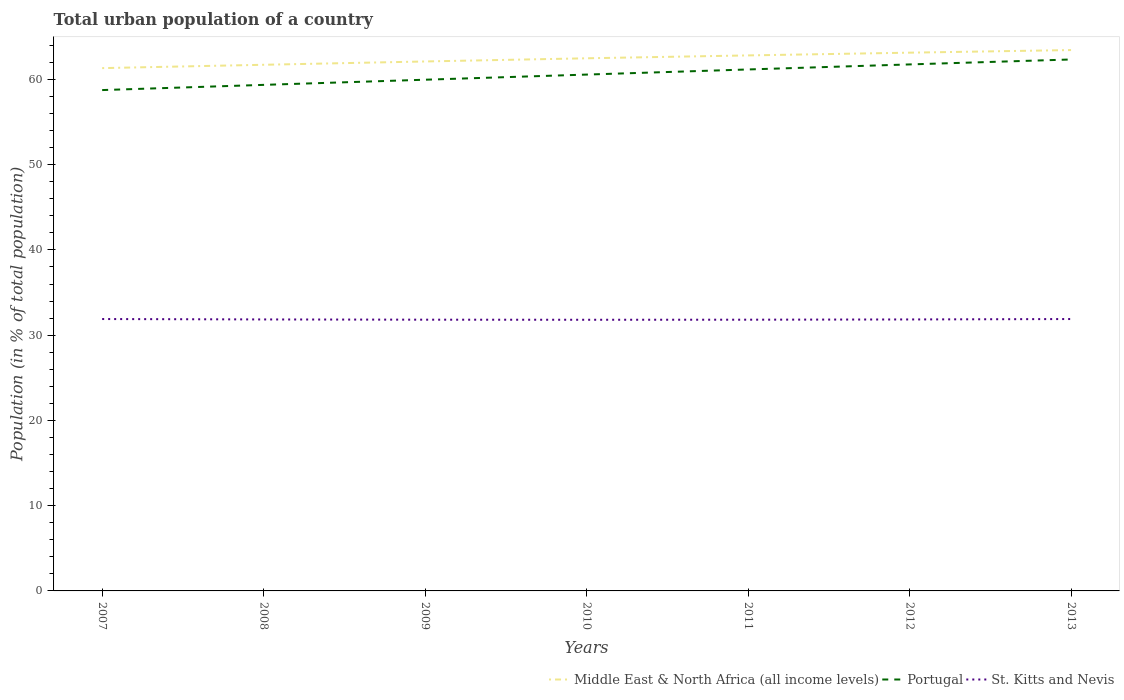How many different coloured lines are there?
Provide a succinct answer. 3. Does the line corresponding to Portugal intersect with the line corresponding to St. Kitts and Nevis?
Make the answer very short. No. Across all years, what is the maximum urban population in St. Kitts and Nevis?
Provide a succinct answer. 31.81. In which year was the urban population in St. Kitts and Nevis maximum?
Your answer should be compact. 2010. What is the total urban population in St. Kitts and Nevis in the graph?
Provide a succinct answer. 0.05. What is the difference between the highest and the second highest urban population in Middle East & North Africa (all income levels)?
Keep it short and to the point. 2.12. How many years are there in the graph?
Ensure brevity in your answer.  7. What is the difference between two consecutive major ticks on the Y-axis?
Provide a succinct answer. 10. Are the values on the major ticks of Y-axis written in scientific E-notation?
Offer a very short reply. No. Does the graph contain any zero values?
Keep it short and to the point. No. Does the graph contain grids?
Offer a terse response. No. What is the title of the graph?
Ensure brevity in your answer.  Total urban population of a country. Does "Lithuania" appear as one of the legend labels in the graph?
Ensure brevity in your answer.  No. What is the label or title of the X-axis?
Offer a terse response. Years. What is the label or title of the Y-axis?
Give a very brief answer. Population (in % of total population). What is the Population (in % of total population) in Middle East & North Africa (all income levels) in 2007?
Your answer should be compact. 61.32. What is the Population (in % of total population) of Portugal in 2007?
Offer a terse response. 58.75. What is the Population (in % of total population) in St. Kitts and Nevis in 2007?
Give a very brief answer. 31.89. What is the Population (in % of total population) in Middle East & North Africa (all income levels) in 2008?
Your answer should be very brief. 61.72. What is the Population (in % of total population) of Portugal in 2008?
Offer a terse response. 59.36. What is the Population (in % of total population) of St. Kitts and Nevis in 2008?
Provide a succinct answer. 31.84. What is the Population (in % of total population) in Middle East & North Africa (all income levels) in 2009?
Provide a short and direct response. 62.1. What is the Population (in % of total population) in Portugal in 2009?
Your answer should be very brief. 59.96. What is the Population (in % of total population) of St. Kitts and Nevis in 2009?
Ensure brevity in your answer.  31.82. What is the Population (in % of total population) of Middle East & North Africa (all income levels) in 2010?
Make the answer very short. 62.48. What is the Population (in % of total population) of Portugal in 2010?
Your answer should be very brief. 60.57. What is the Population (in % of total population) of St. Kitts and Nevis in 2010?
Provide a succinct answer. 31.81. What is the Population (in % of total population) in Middle East & North Africa (all income levels) in 2011?
Give a very brief answer. 62.81. What is the Population (in % of total population) in Portugal in 2011?
Provide a succinct answer. 61.17. What is the Population (in % of total population) of St. Kitts and Nevis in 2011?
Provide a short and direct response. 31.82. What is the Population (in % of total population) of Middle East & North Africa (all income levels) in 2012?
Keep it short and to the point. 63.14. What is the Population (in % of total population) in Portugal in 2012?
Make the answer very short. 61.76. What is the Population (in % of total population) in St. Kitts and Nevis in 2012?
Provide a succinct answer. 31.84. What is the Population (in % of total population) of Middle East & North Africa (all income levels) in 2013?
Provide a succinct answer. 63.44. What is the Population (in % of total population) of Portugal in 2013?
Give a very brief answer. 62.34. What is the Population (in % of total population) of St. Kitts and Nevis in 2013?
Your response must be concise. 31.89. Across all years, what is the maximum Population (in % of total population) of Middle East & North Africa (all income levels)?
Your response must be concise. 63.44. Across all years, what is the maximum Population (in % of total population) of Portugal?
Your response must be concise. 62.34. Across all years, what is the maximum Population (in % of total population) of St. Kitts and Nevis?
Ensure brevity in your answer.  31.89. Across all years, what is the minimum Population (in % of total population) in Middle East & North Africa (all income levels)?
Ensure brevity in your answer.  61.32. Across all years, what is the minimum Population (in % of total population) of Portugal?
Provide a short and direct response. 58.75. Across all years, what is the minimum Population (in % of total population) in St. Kitts and Nevis?
Keep it short and to the point. 31.81. What is the total Population (in % of total population) in Middle East & North Africa (all income levels) in the graph?
Your response must be concise. 437.02. What is the total Population (in % of total population) in Portugal in the graph?
Your answer should be compact. 423.9. What is the total Population (in % of total population) of St. Kitts and Nevis in the graph?
Offer a very short reply. 222.91. What is the difference between the Population (in % of total population) of Middle East & North Africa (all income levels) in 2007 and that in 2008?
Give a very brief answer. -0.39. What is the difference between the Population (in % of total population) of Portugal in 2007 and that in 2008?
Offer a terse response. -0.61. What is the difference between the Population (in % of total population) of St. Kitts and Nevis in 2007 and that in 2008?
Ensure brevity in your answer.  0.05. What is the difference between the Population (in % of total population) in Middle East & North Africa (all income levels) in 2007 and that in 2009?
Offer a terse response. -0.78. What is the difference between the Population (in % of total population) of Portugal in 2007 and that in 2009?
Provide a short and direct response. -1.22. What is the difference between the Population (in % of total population) in St. Kitts and Nevis in 2007 and that in 2009?
Offer a terse response. 0.08. What is the difference between the Population (in % of total population) of Middle East & North Africa (all income levels) in 2007 and that in 2010?
Your answer should be very brief. -1.15. What is the difference between the Population (in % of total population) in Portugal in 2007 and that in 2010?
Give a very brief answer. -1.82. What is the difference between the Population (in % of total population) of St. Kitts and Nevis in 2007 and that in 2010?
Your answer should be compact. 0.09. What is the difference between the Population (in % of total population) of Middle East & North Africa (all income levels) in 2007 and that in 2011?
Make the answer very short. -1.49. What is the difference between the Population (in % of total population) in Portugal in 2007 and that in 2011?
Your answer should be very brief. -2.42. What is the difference between the Population (in % of total population) in St. Kitts and Nevis in 2007 and that in 2011?
Provide a succinct answer. 0.08. What is the difference between the Population (in % of total population) of Middle East & North Africa (all income levels) in 2007 and that in 2012?
Your answer should be very brief. -1.81. What is the difference between the Population (in % of total population) of Portugal in 2007 and that in 2012?
Offer a very short reply. -3.01. What is the difference between the Population (in % of total population) of St. Kitts and Nevis in 2007 and that in 2012?
Make the answer very short. 0.05. What is the difference between the Population (in % of total population) in Middle East & North Africa (all income levels) in 2007 and that in 2013?
Your response must be concise. -2.12. What is the difference between the Population (in % of total population) in Portugal in 2007 and that in 2013?
Ensure brevity in your answer.  -3.59. What is the difference between the Population (in % of total population) in Middle East & North Africa (all income levels) in 2008 and that in 2009?
Your answer should be compact. -0.39. What is the difference between the Population (in % of total population) of Portugal in 2008 and that in 2009?
Your response must be concise. -0.6. What is the difference between the Population (in % of total population) in St. Kitts and Nevis in 2008 and that in 2009?
Provide a succinct answer. 0.03. What is the difference between the Population (in % of total population) in Middle East & North Africa (all income levels) in 2008 and that in 2010?
Ensure brevity in your answer.  -0.76. What is the difference between the Population (in % of total population) of Portugal in 2008 and that in 2010?
Offer a very short reply. -1.21. What is the difference between the Population (in % of total population) in St. Kitts and Nevis in 2008 and that in 2010?
Your answer should be compact. 0.04. What is the difference between the Population (in % of total population) of Middle East & North Africa (all income levels) in 2008 and that in 2011?
Your answer should be compact. -1.1. What is the difference between the Population (in % of total population) of Portugal in 2008 and that in 2011?
Provide a succinct answer. -1.81. What is the difference between the Population (in % of total population) in St. Kitts and Nevis in 2008 and that in 2011?
Your response must be concise. 0.03. What is the difference between the Population (in % of total population) of Middle East & North Africa (all income levels) in 2008 and that in 2012?
Make the answer very short. -1.42. What is the difference between the Population (in % of total population) of Portugal in 2008 and that in 2012?
Offer a very short reply. -2.4. What is the difference between the Population (in % of total population) of Middle East & North Africa (all income levels) in 2008 and that in 2013?
Offer a very short reply. -1.73. What is the difference between the Population (in % of total population) in Portugal in 2008 and that in 2013?
Make the answer very short. -2.98. What is the difference between the Population (in % of total population) in St. Kitts and Nevis in 2008 and that in 2013?
Make the answer very short. -0.05. What is the difference between the Population (in % of total population) of Middle East & North Africa (all income levels) in 2009 and that in 2010?
Your answer should be very brief. -0.37. What is the difference between the Population (in % of total population) of Portugal in 2009 and that in 2010?
Ensure brevity in your answer.  -0.6. What is the difference between the Population (in % of total population) in St. Kitts and Nevis in 2009 and that in 2010?
Offer a terse response. 0.01. What is the difference between the Population (in % of total population) in Middle East & North Africa (all income levels) in 2009 and that in 2011?
Offer a very short reply. -0.71. What is the difference between the Population (in % of total population) of Portugal in 2009 and that in 2011?
Your response must be concise. -1.2. What is the difference between the Population (in % of total population) of St. Kitts and Nevis in 2009 and that in 2011?
Offer a very short reply. 0. What is the difference between the Population (in % of total population) in Middle East & North Africa (all income levels) in 2009 and that in 2012?
Offer a very short reply. -1.03. What is the difference between the Population (in % of total population) in Portugal in 2009 and that in 2012?
Give a very brief answer. -1.79. What is the difference between the Population (in % of total population) of St. Kitts and Nevis in 2009 and that in 2012?
Offer a terse response. -0.03. What is the difference between the Population (in % of total population) in Middle East & North Africa (all income levels) in 2009 and that in 2013?
Provide a succinct answer. -1.34. What is the difference between the Population (in % of total population) of Portugal in 2009 and that in 2013?
Offer a very short reply. -2.37. What is the difference between the Population (in % of total population) in St. Kitts and Nevis in 2009 and that in 2013?
Give a very brief answer. -0.08. What is the difference between the Population (in % of total population) of Middle East & North Africa (all income levels) in 2010 and that in 2011?
Provide a short and direct response. -0.34. What is the difference between the Population (in % of total population) of Portugal in 2010 and that in 2011?
Your answer should be very brief. -0.6. What is the difference between the Population (in % of total population) in St. Kitts and Nevis in 2010 and that in 2011?
Offer a very short reply. -0.01. What is the difference between the Population (in % of total population) of Middle East & North Africa (all income levels) in 2010 and that in 2012?
Provide a short and direct response. -0.66. What is the difference between the Population (in % of total population) in Portugal in 2010 and that in 2012?
Your answer should be very brief. -1.19. What is the difference between the Population (in % of total population) in St. Kitts and Nevis in 2010 and that in 2012?
Your answer should be compact. -0.04. What is the difference between the Population (in % of total population) in Middle East & North Africa (all income levels) in 2010 and that in 2013?
Your answer should be compact. -0.97. What is the difference between the Population (in % of total population) in Portugal in 2010 and that in 2013?
Make the answer very short. -1.77. What is the difference between the Population (in % of total population) of St. Kitts and Nevis in 2010 and that in 2013?
Your response must be concise. -0.09. What is the difference between the Population (in % of total population) of Middle East & North Africa (all income levels) in 2011 and that in 2012?
Keep it short and to the point. -0.32. What is the difference between the Population (in % of total population) of Portugal in 2011 and that in 2012?
Your response must be concise. -0.59. What is the difference between the Population (in % of total population) of St. Kitts and Nevis in 2011 and that in 2012?
Provide a short and direct response. -0.03. What is the difference between the Population (in % of total population) in Middle East & North Africa (all income levels) in 2011 and that in 2013?
Make the answer very short. -0.63. What is the difference between the Population (in % of total population) of Portugal in 2011 and that in 2013?
Ensure brevity in your answer.  -1.17. What is the difference between the Population (in % of total population) of St. Kitts and Nevis in 2011 and that in 2013?
Your response must be concise. -0.08. What is the difference between the Population (in % of total population) in Middle East & North Africa (all income levels) in 2012 and that in 2013?
Make the answer very short. -0.31. What is the difference between the Population (in % of total population) of Portugal in 2012 and that in 2013?
Your answer should be very brief. -0.58. What is the difference between the Population (in % of total population) of St. Kitts and Nevis in 2012 and that in 2013?
Your answer should be very brief. -0.05. What is the difference between the Population (in % of total population) of Middle East & North Africa (all income levels) in 2007 and the Population (in % of total population) of Portugal in 2008?
Ensure brevity in your answer.  1.97. What is the difference between the Population (in % of total population) of Middle East & North Africa (all income levels) in 2007 and the Population (in % of total population) of St. Kitts and Nevis in 2008?
Provide a succinct answer. 29.48. What is the difference between the Population (in % of total population) of Portugal in 2007 and the Population (in % of total population) of St. Kitts and Nevis in 2008?
Your response must be concise. 26.9. What is the difference between the Population (in % of total population) in Middle East & North Africa (all income levels) in 2007 and the Population (in % of total population) in Portugal in 2009?
Provide a short and direct response. 1.36. What is the difference between the Population (in % of total population) in Middle East & North Africa (all income levels) in 2007 and the Population (in % of total population) in St. Kitts and Nevis in 2009?
Give a very brief answer. 29.51. What is the difference between the Population (in % of total population) of Portugal in 2007 and the Population (in % of total population) of St. Kitts and Nevis in 2009?
Provide a succinct answer. 26.93. What is the difference between the Population (in % of total population) in Middle East & North Africa (all income levels) in 2007 and the Population (in % of total population) in Portugal in 2010?
Your answer should be very brief. 0.76. What is the difference between the Population (in % of total population) in Middle East & North Africa (all income levels) in 2007 and the Population (in % of total population) in St. Kitts and Nevis in 2010?
Your response must be concise. 29.52. What is the difference between the Population (in % of total population) of Portugal in 2007 and the Population (in % of total population) of St. Kitts and Nevis in 2010?
Your answer should be very brief. 26.94. What is the difference between the Population (in % of total population) in Middle East & North Africa (all income levels) in 2007 and the Population (in % of total population) in Portugal in 2011?
Give a very brief answer. 0.16. What is the difference between the Population (in % of total population) of Middle East & North Africa (all income levels) in 2007 and the Population (in % of total population) of St. Kitts and Nevis in 2011?
Provide a succinct answer. 29.51. What is the difference between the Population (in % of total population) in Portugal in 2007 and the Population (in % of total population) in St. Kitts and Nevis in 2011?
Offer a very short reply. 26.93. What is the difference between the Population (in % of total population) in Middle East & North Africa (all income levels) in 2007 and the Population (in % of total population) in Portugal in 2012?
Provide a short and direct response. -0.43. What is the difference between the Population (in % of total population) in Middle East & North Africa (all income levels) in 2007 and the Population (in % of total population) in St. Kitts and Nevis in 2012?
Ensure brevity in your answer.  29.48. What is the difference between the Population (in % of total population) of Portugal in 2007 and the Population (in % of total population) of St. Kitts and Nevis in 2012?
Give a very brief answer. 26.91. What is the difference between the Population (in % of total population) in Middle East & North Africa (all income levels) in 2007 and the Population (in % of total population) in Portugal in 2013?
Provide a succinct answer. -1.01. What is the difference between the Population (in % of total population) in Middle East & North Africa (all income levels) in 2007 and the Population (in % of total population) in St. Kitts and Nevis in 2013?
Provide a succinct answer. 29.43. What is the difference between the Population (in % of total population) of Portugal in 2007 and the Population (in % of total population) of St. Kitts and Nevis in 2013?
Provide a short and direct response. 26.86. What is the difference between the Population (in % of total population) of Middle East & North Africa (all income levels) in 2008 and the Population (in % of total population) of Portugal in 2009?
Give a very brief answer. 1.75. What is the difference between the Population (in % of total population) of Middle East & North Africa (all income levels) in 2008 and the Population (in % of total population) of St. Kitts and Nevis in 2009?
Your answer should be very brief. 29.9. What is the difference between the Population (in % of total population) in Portugal in 2008 and the Population (in % of total population) in St. Kitts and Nevis in 2009?
Your answer should be compact. 27.54. What is the difference between the Population (in % of total population) of Middle East & North Africa (all income levels) in 2008 and the Population (in % of total population) of Portugal in 2010?
Give a very brief answer. 1.15. What is the difference between the Population (in % of total population) in Middle East & North Africa (all income levels) in 2008 and the Population (in % of total population) in St. Kitts and Nevis in 2010?
Offer a terse response. 29.91. What is the difference between the Population (in % of total population) of Portugal in 2008 and the Population (in % of total population) of St. Kitts and Nevis in 2010?
Keep it short and to the point. 27.55. What is the difference between the Population (in % of total population) in Middle East & North Africa (all income levels) in 2008 and the Population (in % of total population) in Portugal in 2011?
Offer a very short reply. 0.55. What is the difference between the Population (in % of total population) of Middle East & North Africa (all income levels) in 2008 and the Population (in % of total population) of St. Kitts and Nevis in 2011?
Provide a succinct answer. 29.9. What is the difference between the Population (in % of total population) of Portugal in 2008 and the Population (in % of total population) of St. Kitts and Nevis in 2011?
Provide a succinct answer. 27.54. What is the difference between the Population (in % of total population) of Middle East & North Africa (all income levels) in 2008 and the Population (in % of total population) of Portugal in 2012?
Provide a succinct answer. -0.04. What is the difference between the Population (in % of total population) in Middle East & North Africa (all income levels) in 2008 and the Population (in % of total population) in St. Kitts and Nevis in 2012?
Your answer should be compact. 29.87. What is the difference between the Population (in % of total population) of Portugal in 2008 and the Population (in % of total population) of St. Kitts and Nevis in 2012?
Your response must be concise. 27.52. What is the difference between the Population (in % of total population) of Middle East & North Africa (all income levels) in 2008 and the Population (in % of total population) of Portugal in 2013?
Make the answer very short. -0.62. What is the difference between the Population (in % of total population) of Middle East & North Africa (all income levels) in 2008 and the Population (in % of total population) of St. Kitts and Nevis in 2013?
Provide a short and direct response. 29.82. What is the difference between the Population (in % of total population) of Portugal in 2008 and the Population (in % of total population) of St. Kitts and Nevis in 2013?
Keep it short and to the point. 27.47. What is the difference between the Population (in % of total population) in Middle East & North Africa (all income levels) in 2009 and the Population (in % of total population) in Portugal in 2010?
Ensure brevity in your answer.  1.54. What is the difference between the Population (in % of total population) of Middle East & North Africa (all income levels) in 2009 and the Population (in % of total population) of St. Kitts and Nevis in 2010?
Your response must be concise. 30.3. What is the difference between the Population (in % of total population) in Portugal in 2009 and the Population (in % of total population) in St. Kitts and Nevis in 2010?
Your answer should be compact. 28.16. What is the difference between the Population (in % of total population) in Middle East & North Africa (all income levels) in 2009 and the Population (in % of total population) in Portugal in 2011?
Give a very brief answer. 0.94. What is the difference between the Population (in % of total population) of Middle East & North Africa (all income levels) in 2009 and the Population (in % of total population) of St. Kitts and Nevis in 2011?
Your answer should be compact. 30.29. What is the difference between the Population (in % of total population) of Portugal in 2009 and the Population (in % of total population) of St. Kitts and Nevis in 2011?
Ensure brevity in your answer.  28.15. What is the difference between the Population (in % of total population) of Middle East & North Africa (all income levels) in 2009 and the Population (in % of total population) of Portugal in 2012?
Ensure brevity in your answer.  0.35. What is the difference between the Population (in % of total population) in Middle East & North Africa (all income levels) in 2009 and the Population (in % of total population) in St. Kitts and Nevis in 2012?
Offer a terse response. 30.26. What is the difference between the Population (in % of total population) of Portugal in 2009 and the Population (in % of total population) of St. Kitts and Nevis in 2012?
Your response must be concise. 28.12. What is the difference between the Population (in % of total population) in Middle East & North Africa (all income levels) in 2009 and the Population (in % of total population) in Portugal in 2013?
Give a very brief answer. -0.23. What is the difference between the Population (in % of total population) in Middle East & North Africa (all income levels) in 2009 and the Population (in % of total population) in St. Kitts and Nevis in 2013?
Your response must be concise. 30.21. What is the difference between the Population (in % of total population) of Portugal in 2009 and the Population (in % of total population) of St. Kitts and Nevis in 2013?
Your response must be concise. 28.07. What is the difference between the Population (in % of total population) of Middle East & North Africa (all income levels) in 2010 and the Population (in % of total population) of Portugal in 2011?
Make the answer very short. 1.31. What is the difference between the Population (in % of total population) in Middle East & North Africa (all income levels) in 2010 and the Population (in % of total population) in St. Kitts and Nevis in 2011?
Give a very brief answer. 30.66. What is the difference between the Population (in % of total population) of Portugal in 2010 and the Population (in % of total population) of St. Kitts and Nevis in 2011?
Make the answer very short. 28.75. What is the difference between the Population (in % of total population) in Middle East & North Africa (all income levels) in 2010 and the Population (in % of total population) in Portugal in 2012?
Offer a very short reply. 0.72. What is the difference between the Population (in % of total population) in Middle East & North Africa (all income levels) in 2010 and the Population (in % of total population) in St. Kitts and Nevis in 2012?
Provide a short and direct response. 30.63. What is the difference between the Population (in % of total population) of Portugal in 2010 and the Population (in % of total population) of St. Kitts and Nevis in 2012?
Offer a very short reply. 28.72. What is the difference between the Population (in % of total population) of Middle East & North Africa (all income levels) in 2010 and the Population (in % of total population) of Portugal in 2013?
Provide a short and direct response. 0.14. What is the difference between the Population (in % of total population) of Middle East & North Africa (all income levels) in 2010 and the Population (in % of total population) of St. Kitts and Nevis in 2013?
Ensure brevity in your answer.  30.59. What is the difference between the Population (in % of total population) of Portugal in 2010 and the Population (in % of total population) of St. Kitts and Nevis in 2013?
Give a very brief answer. 28.68. What is the difference between the Population (in % of total population) of Middle East & North Africa (all income levels) in 2011 and the Population (in % of total population) of Portugal in 2012?
Provide a succinct answer. 1.06. What is the difference between the Population (in % of total population) of Middle East & North Africa (all income levels) in 2011 and the Population (in % of total population) of St. Kitts and Nevis in 2012?
Provide a short and direct response. 30.97. What is the difference between the Population (in % of total population) of Portugal in 2011 and the Population (in % of total population) of St. Kitts and Nevis in 2012?
Make the answer very short. 29.32. What is the difference between the Population (in % of total population) of Middle East & North Africa (all income levels) in 2011 and the Population (in % of total population) of Portugal in 2013?
Your response must be concise. 0.48. What is the difference between the Population (in % of total population) in Middle East & North Africa (all income levels) in 2011 and the Population (in % of total population) in St. Kitts and Nevis in 2013?
Offer a very short reply. 30.92. What is the difference between the Population (in % of total population) in Portugal in 2011 and the Population (in % of total population) in St. Kitts and Nevis in 2013?
Your answer should be very brief. 29.27. What is the difference between the Population (in % of total population) in Middle East & North Africa (all income levels) in 2012 and the Population (in % of total population) in Portugal in 2013?
Give a very brief answer. 0.8. What is the difference between the Population (in % of total population) in Middle East & North Africa (all income levels) in 2012 and the Population (in % of total population) in St. Kitts and Nevis in 2013?
Provide a succinct answer. 31.24. What is the difference between the Population (in % of total population) in Portugal in 2012 and the Population (in % of total population) in St. Kitts and Nevis in 2013?
Give a very brief answer. 29.87. What is the average Population (in % of total population) of Middle East & North Africa (all income levels) per year?
Give a very brief answer. 62.43. What is the average Population (in % of total population) in Portugal per year?
Make the answer very short. 60.56. What is the average Population (in % of total population) of St. Kitts and Nevis per year?
Your answer should be compact. 31.84. In the year 2007, what is the difference between the Population (in % of total population) of Middle East & North Africa (all income levels) and Population (in % of total population) of Portugal?
Provide a short and direct response. 2.58. In the year 2007, what is the difference between the Population (in % of total population) in Middle East & North Africa (all income levels) and Population (in % of total population) in St. Kitts and Nevis?
Your answer should be compact. 29.43. In the year 2007, what is the difference between the Population (in % of total population) of Portugal and Population (in % of total population) of St. Kitts and Nevis?
Your answer should be very brief. 26.86. In the year 2008, what is the difference between the Population (in % of total population) of Middle East & North Africa (all income levels) and Population (in % of total population) of Portugal?
Your response must be concise. 2.36. In the year 2008, what is the difference between the Population (in % of total population) in Middle East & North Africa (all income levels) and Population (in % of total population) in St. Kitts and Nevis?
Make the answer very short. 29.87. In the year 2008, what is the difference between the Population (in % of total population) in Portugal and Population (in % of total population) in St. Kitts and Nevis?
Your response must be concise. 27.51. In the year 2009, what is the difference between the Population (in % of total population) in Middle East & North Africa (all income levels) and Population (in % of total population) in Portugal?
Make the answer very short. 2.14. In the year 2009, what is the difference between the Population (in % of total population) of Middle East & North Africa (all income levels) and Population (in % of total population) of St. Kitts and Nevis?
Offer a terse response. 30.29. In the year 2009, what is the difference between the Population (in % of total population) in Portugal and Population (in % of total population) in St. Kitts and Nevis?
Your answer should be very brief. 28.15. In the year 2010, what is the difference between the Population (in % of total population) in Middle East & North Africa (all income levels) and Population (in % of total population) in Portugal?
Your response must be concise. 1.91. In the year 2010, what is the difference between the Population (in % of total population) of Middle East & North Africa (all income levels) and Population (in % of total population) of St. Kitts and Nevis?
Your answer should be very brief. 30.67. In the year 2010, what is the difference between the Population (in % of total population) in Portugal and Population (in % of total population) in St. Kitts and Nevis?
Keep it short and to the point. 28.76. In the year 2011, what is the difference between the Population (in % of total population) of Middle East & North Africa (all income levels) and Population (in % of total population) of Portugal?
Offer a terse response. 1.65. In the year 2011, what is the difference between the Population (in % of total population) in Middle East & North Africa (all income levels) and Population (in % of total population) in St. Kitts and Nevis?
Your response must be concise. 31. In the year 2011, what is the difference between the Population (in % of total population) of Portugal and Population (in % of total population) of St. Kitts and Nevis?
Your answer should be very brief. 29.35. In the year 2012, what is the difference between the Population (in % of total population) of Middle East & North Africa (all income levels) and Population (in % of total population) of Portugal?
Ensure brevity in your answer.  1.38. In the year 2012, what is the difference between the Population (in % of total population) in Middle East & North Africa (all income levels) and Population (in % of total population) in St. Kitts and Nevis?
Provide a succinct answer. 31.29. In the year 2012, what is the difference between the Population (in % of total population) of Portugal and Population (in % of total population) of St. Kitts and Nevis?
Make the answer very short. 29.91. In the year 2013, what is the difference between the Population (in % of total population) of Middle East & North Africa (all income levels) and Population (in % of total population) of Portugal?
Offer a terse response. 1.1. In the year 2013, what is the difference between the Population (in % of total population) in Middle East & North Africa (all income levels) and Population (in % of total population) in St. Kitts and Nevis?
Your response must be concise. 31.55. In the year 2013, what is the difference between the Population (in % of total population) of Portugal and Population (in % of total population) of St. Kitts and Nevis?
Give a very brief answer. 30.45. What is the ratio of the Population (in % of total population) in Middle East & North Africa (all income levels) in 2007 to that in 2008?
Give a very brief answer. 0.99. What is the ratio of the Population (in % of total population) of Portugal in 2007 to that in 2008?
Offer a very short reply. 0.99. What is the ratio of the Population (in % of total population) in Middle East & North Africa (all income levels) in 2007 to that in 2009?
Provide a short and direct response. 0.99. What is the ratio of the Population (in % of total population) in Portugal in 2007 to that in 2009?
Offer a very short reply. 0.98. What is the ratio of the Population (in % of total population) in St. Kitts and Nevis in 2007 to that in 2009?
Provide a succinct answer. 1. What is the ratio of the Population (in % of total population) in Middle East & North Africa (all income levels) in 2007 to that in 2010?
Your response must be concise. 0.98. What is the ratio of the Population (in % of total population) of Portugal in 2007 to that in 2010?
Your answer should be very brief. 0.97. What is the ratio of the Population (in % of total population) in Middle East & North Africa (all income levels) in 2007 to that in 2011?
Make the answer very short. 0.98. What is the ratio of the Population (in % of total population) in Portugal in 2007 to that in 2011?
Your response must be concise. 0.96. What is the ratio of the Population (in % of total population) of St. Kitts and Nevis in 2007 to that in 2011?
Offer a terse response. 1. What is the ratio of the Population (in % of total population) of Middle East & North Africa (all income levels) in 2007 to that in 2012?
Offer a terse response. 0.97. What is the ratio of the Population (in % of total population) in Portugal in 2007 to that in 2012?
Provide a short and direct response. 0.95. What is the ratio of the Population (in % of total population) of St. Kitts and Nevis in 2007 to that in 2012?
Ensure brevity in your answer.  1. What is the ratio of the Population (in % of total population) of Middle East & North Africa (all income levels) in 2007 to that in 2013?
Ensure brevity in your answer.  0.97. What is the ratio of the Population (in % of total population) in Portugal in 2007 to that in 2013?
Provide a succinct answer. 0.94. What is the ratio of the Population (in % of total population) in Portugal in 2008 to that in 2010?
Offer a terse response. 0.98. What is the ratio of the Population (in % of total population) in St. Kitts and Nevis in 2008 to that in 2010?
Provide a short and direct response. 1. What is the ratio of the Population (in % of total population) of Middle East & North Africa (all income levels) in 2008 to that in 2011?
Make the answer very short. 0.98. What is the ratio of the Population (in % of total population) of Portugal in 2008 to that in 2011?
Give a very brief answer. 0.97. What is the ratio of the Population (in % of total population) of Middle East & North Africa (all income levels) in 2008 to that in 2012?
Your answer should be compact. 0.98. What is the ratio of the Population (in % of total population) in Portugal in 2008 to that in 2012?
Your answer should be compact. 0.96. What is the ratio of the Population (in % of total population) in St. Kitts and Nevis in 2008 to that in 2012?
Provide a succinct answer. 1. What is the ratio of the Population (in % of total population) of Middle East & North Africa (all income levels) in 2008 to that in 2013?
Offer a very short reply. 0.97. What is the ratio of the Population (in % of total population) of Portugal in 2008 to that in 2013?
Provide a short and direct response. 0.95. What is the ratio of the Population (in % of total population) of St. Kitts and Nevis in 2008 to that in 2013?
Provide a succinct answer. 1. What is the ratio of the Population (in % of total population) of Portugal in 2009 to that in 2010?
Offer a very short reply. 0.99. What is the ratio of the Population (in % of total population) in Middle East & North Africa (all income levels) in 2009 to that in 2011?
Your response must be concise. 0.99. What is the ratio of the Population (in % of total population) in Portugal in 2009 to that in 2011?
Your response must be concise. 0.98. What is the ratio of the Population (in % of total population) in Middle East & North Africa (all income levels) in 2009 to that in 2012?
Provide a short and direct response. 0.98. What is the ratio of the Population (in % of total population) of Portugal in 2009 to that in 2012?
Your response must be concise. 0.97. What is the ratio of the Population (in % of total population) in Middle East & North Africa (all income levels) in 2009 to that in 2013?
Provide a short and direct response. 0.98. What is the ratio of the Population (in % of total population) of Portugal in 2009 to that in 2013?
Your answer should be compact. 0.96. What is the ratio of the Population (in % of total population) in St. Kitts and Nevis in 2009 to that in 2013?
Give a very brief answer. 1. What is the ratio of the Population (in % of total population) in Portugal in 2010 to that in 2011?
Provide a succinct answer. 0.99. What is the ratio of the Population (in % of total population) in St. Kitts and Nevis in 2010 to that in 2011?
Your answer should be compact. 1. What is the ratio of the Population (in % of total population) in Portugal in 2010 to that in 2012?
Offer a very short reply. 0.98. What is the ratio of the Population (in % of total population) in St. Kitts and Nevis in 2010 to that in 2012?
Give a very brief answer. 1. What is the ratio of the Population (in % of total population) in Portugal in 2010 to that in 2013?
Ensure brevity in your answer.  0.97. What is the ratio of the Population (in % of total population) of St. Kitts and Nevis in 2010 to that in 2013?
Offer a terse response. 1. What is the ratio of the Population (in % of total population) in St. Kitts and Nevis in 2011 to that in 2012?
Keep it short and to the point. 1. What is the ratio of the Population (in % of total population) in Portugal in 2011 to that in 2013?
Offer a terse response. 0.98. What is the ratio of the Population (in % of total population) of Portugal in 2012 to that in 2013?
Offer a very short reply. 0.99. What is the difference between the highest and the second highest Population (in % of total population) in Middle East & North Africa (all income levels)?
Your response must be concise. 0.31. What is the difference between the highest and the second highest Population (in % of total population) of Portugal?
Offer a very short reply. 0.58. What is the difference between the highest and the second highest Population (in % of total population) of St. Kitts and Nevis?
Keep it short and to the point. 0. What is the difference between the highest and the lowest Population (in % of total population) in Middle East & North Africa (all income levels)?
Ensure brevity in your answer.  2.12. What is the difference between the highest and the lowest Population (in % of total population) of Portugal?
Keep it short and to the point. 3.59. What is the difference between the highest and the lowest Population (in % of total population) of St. Kitts and Nevis?
Provide a succinct answer. 0.09. 